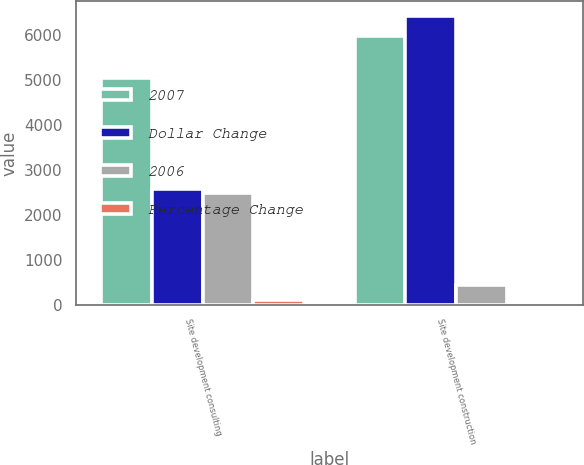Convert chart. <chart><loc_0><loc_0><loc_500><loc_500><stacked_bar_chart><ecel><fcel>Site development consulting<fcel>Site development construction<nl><fcel>2007<fcel>5054<fcel>5982<nl><fcel>Dollar Change<fcel>2578<fcel>6431<nl><fcel>2006<fcel>2476<fcel>449<nl><fcel>Percentage Change<fcel>96<fcel>7<nl></chart> 